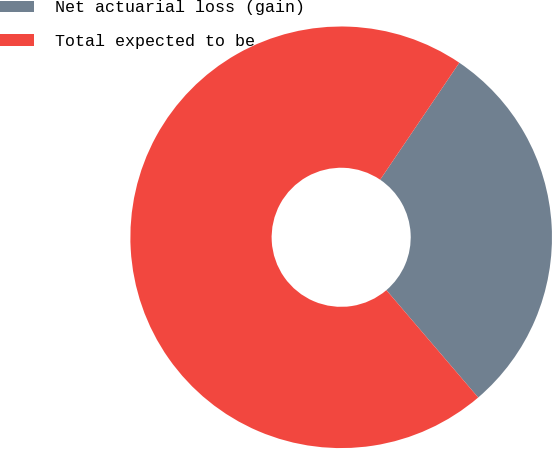Convert chart. <chart><loc_0><loc_0><loc_500><loc_500><pie_chart><fcel>Net actuarial loss (gain)<fcel>Total expected to be<nl><fcel>29.27%<fcel>70.73%<nl></chart> 